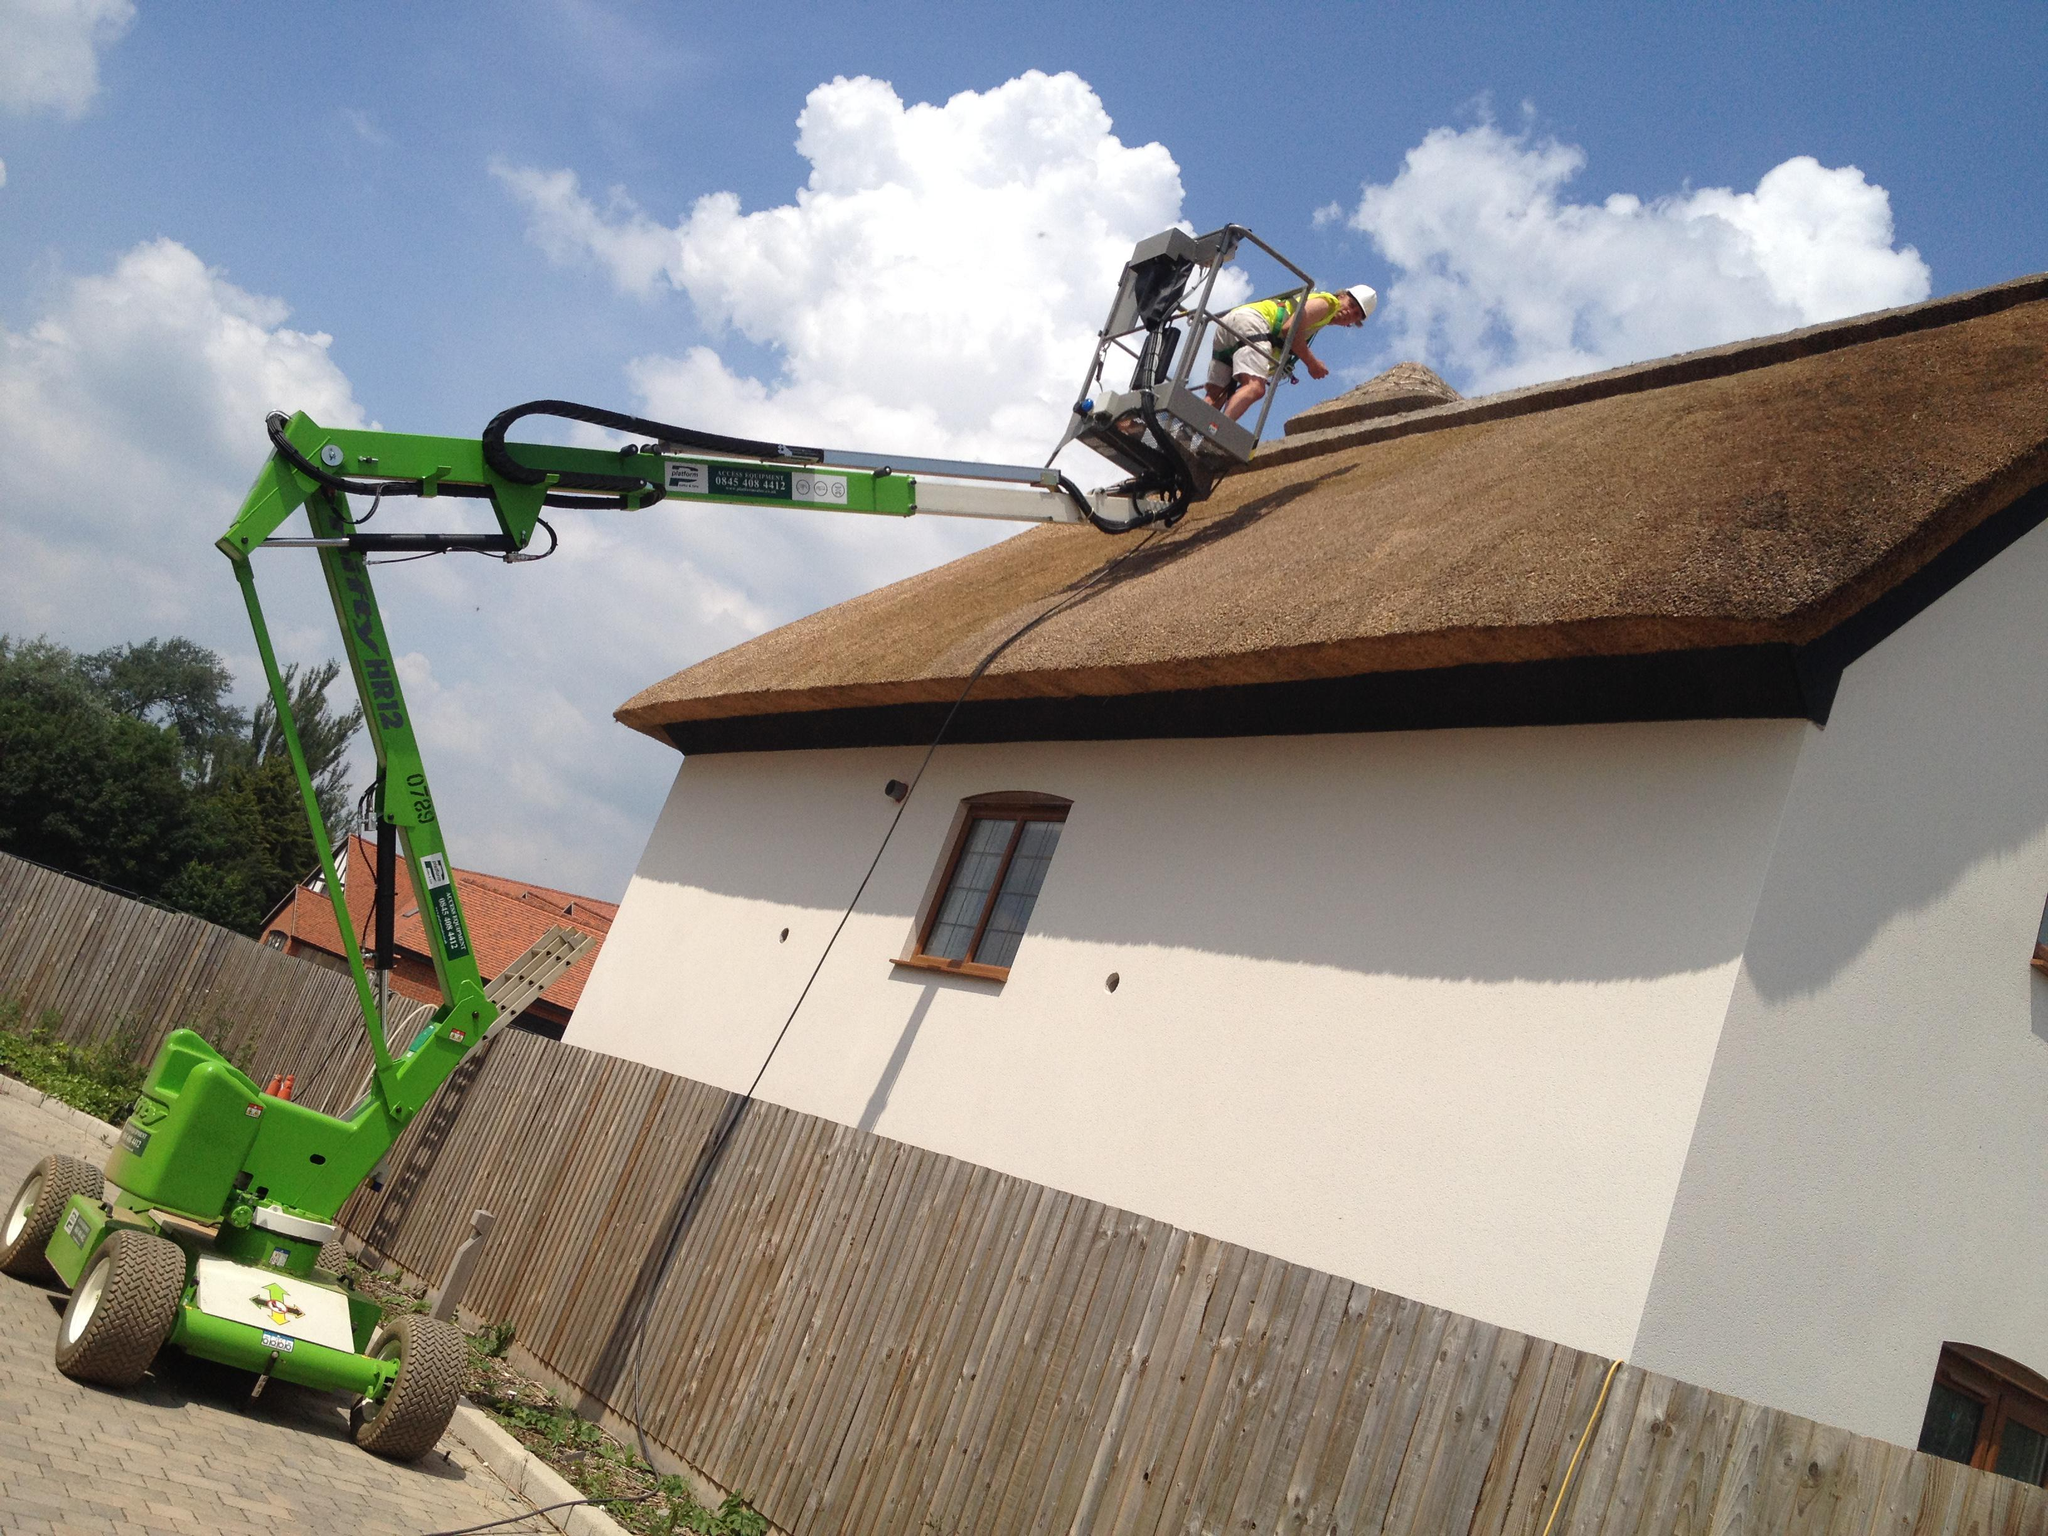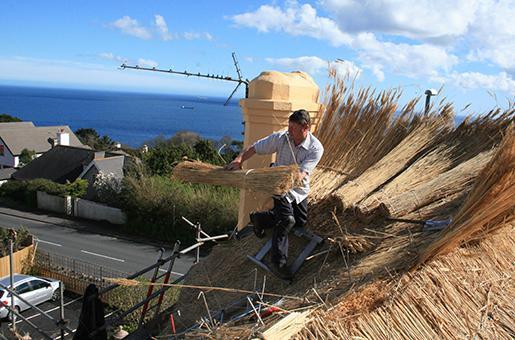The first image is the image on the left, the second image is the image on the right. Considering the images on both sides, is "In at least one image there is a white house with two windows, a straw roof and two chimneys." valid? Answer yes or no. No. The first image is the image on the left, the second image is the image on the right. Analyze the images presented: Is the assertion "One image shows a rectangular white building with a single window flanking each side of the door, a chimney on each end, and a roof with a straight bottom edge bordered with a dotted line of stones." valid? Answer yes or no. No. 